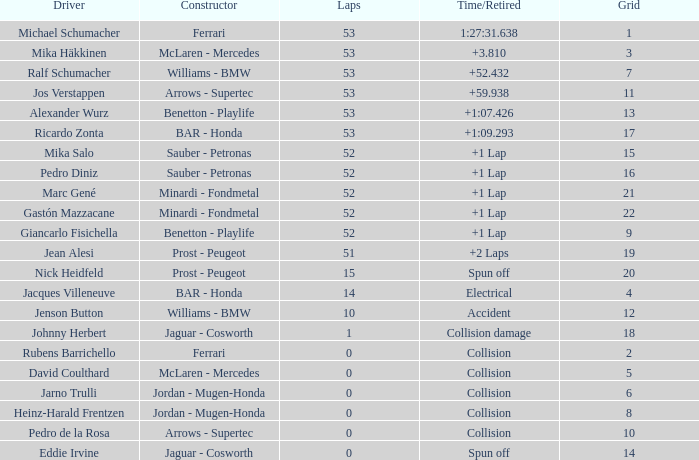What is the grid number with less than 52 laps and a Time/Retired of collision, and a Constructor of arrows - supertec? 1.0. 